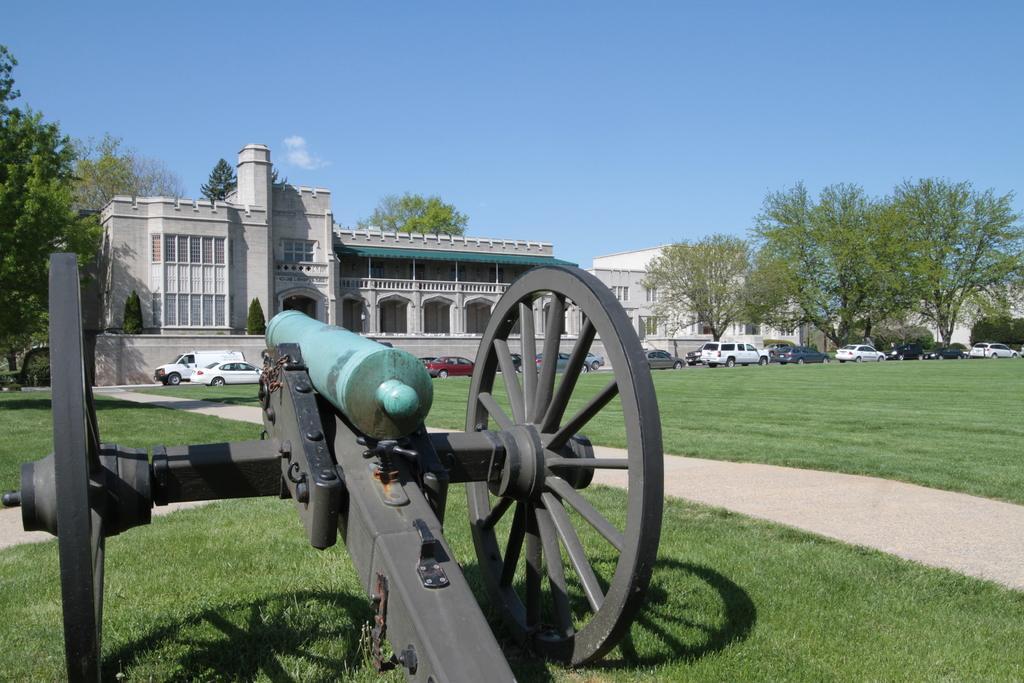How would you summarize this image in a sentence or two? This is an outside view. On the left side of this image I can see a cart in the garden. Beside that there is a path. In the background there are some cars on the road and also I can see few buildings and trees. At the top I can see the sky. 